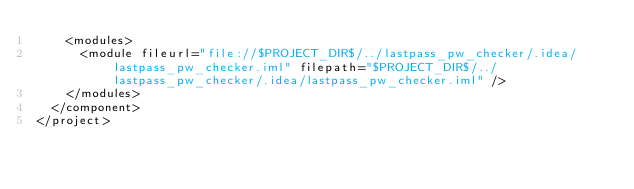<code> <loc_0><loc_0><loc_500><loc_500><_XML_>    <modules>
      <module fileurl="file://$PROJECT_DIR$/../lastpass_pw_checker/.idea/lastpass_pw_checker.iml" filepath="$PROJECT_DIR$/../lastpass_pw_checker/.idea/lastpass_pw_checker.iml" />
    </modules>
  </component>
</project></code> 